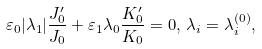<formula> <loc_0><loc_0><loc_500><loc_500>\varepsilon _ { 0 } | \lambda _ { 1 } | \frac { J _ { 0 } ^ { \prime } } { J _ { 0 } } + \varepsilon _ { 1 } \lambda _ { 0 } \frac { K _ { 0 } ^ { \prime } } { K _ { 0 } } = 0 , \, \lambda _ { i } = \lambda _ { i } ^ { ( 0 ) } ,</formula> 